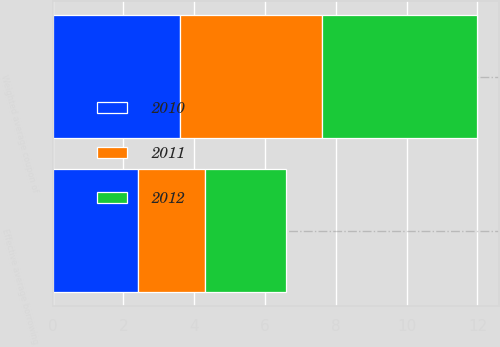Convert chart to OTSL. <chart><loc_0><loc_0><loc_500><loc_500><stacked_bar_chart><ecel><fcel>Weighted average coupon of<fcel>Effective average borrowing<nl><fcel>2012<fcel>4.4<fcel>2.3<nl><fcel>2011<fcel>4<fcel>1.9<nl><fcel>2010<fcel>3.6<fcel>2.4<nl></chart> 